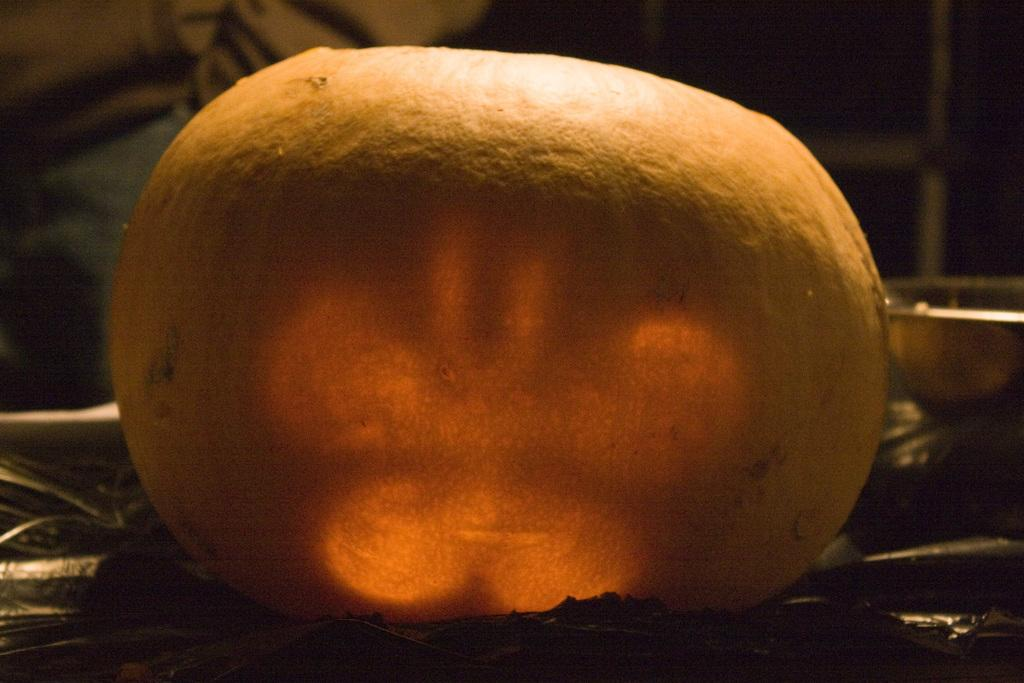What is the overall color scheme of the image? The background of the image is dark. What stands out in the image due to its color? There is a yellow object in the image. What does the yellow object resemble? The yellow object resembles a pumpkin. What type of wheel is attached to the mother in the image? There is no wheel or mother present in the image; it features a yellow object that resembles a pumpkin. 